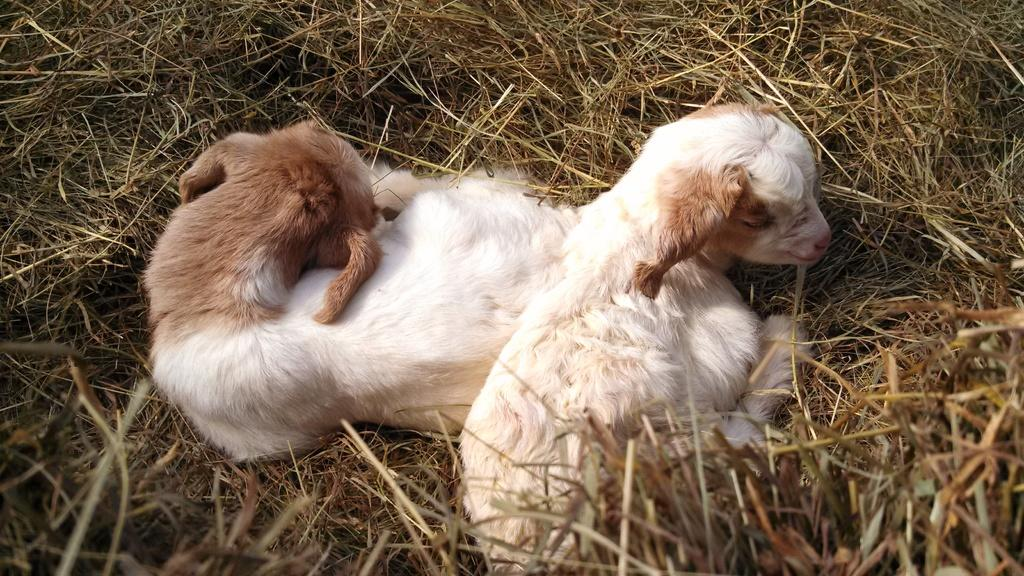How many animals are present in the image? There are two animals in the image. What is the surface on which the animals are located? The animals are on the grass. What is the rate at which the sugar is being consumed by the animals in the image? There is no sugar present in the image, and therefore no consumption can be observed. 